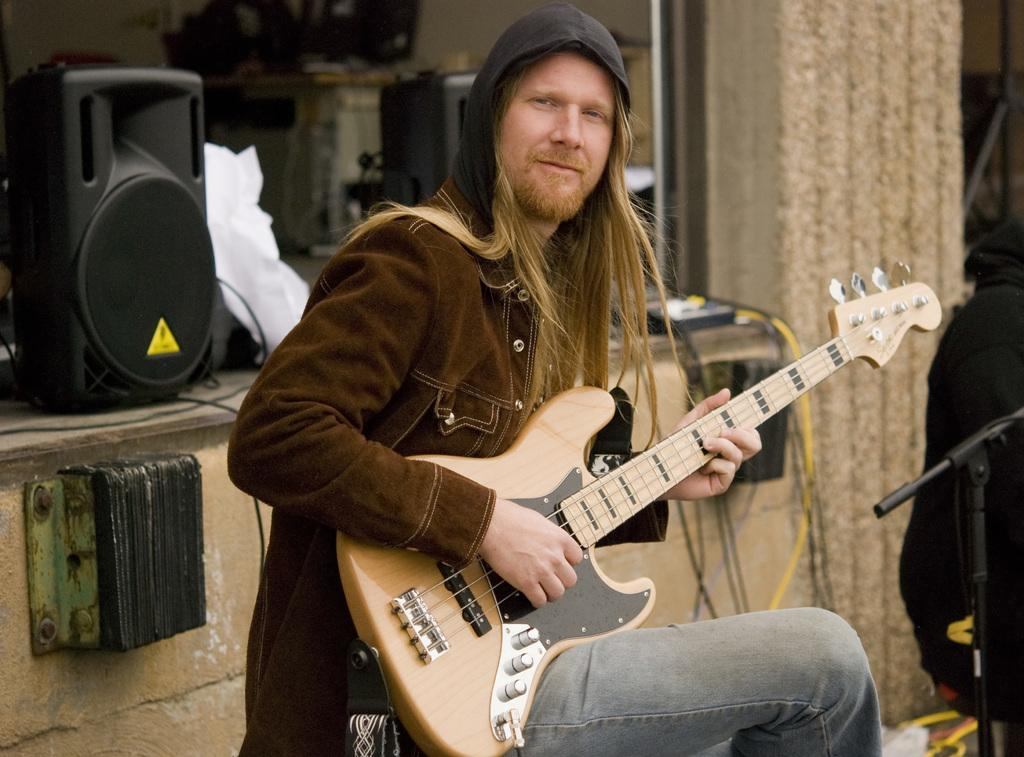What is the man in the image doing? The man is sitting and playing a guitar in the image. What object is present in the image that is typically used for amplifying sound? There is a speaker in the image, which is used for amplifying sound. What is the color of the speaker in the image? The speaker in the image is black in color. What object is present in the image that is typically used for amplifying the voice of a performer? There is a microphone stand in the image, which is typically used for amplifying the voice of a performer. What type of rake is being used to play the guitar in the image? There is no rake present in the image, and the man is playing a guitar, not a rake. How many bottles can be seen on the stage in the image? There are no bottles visible in the image. 